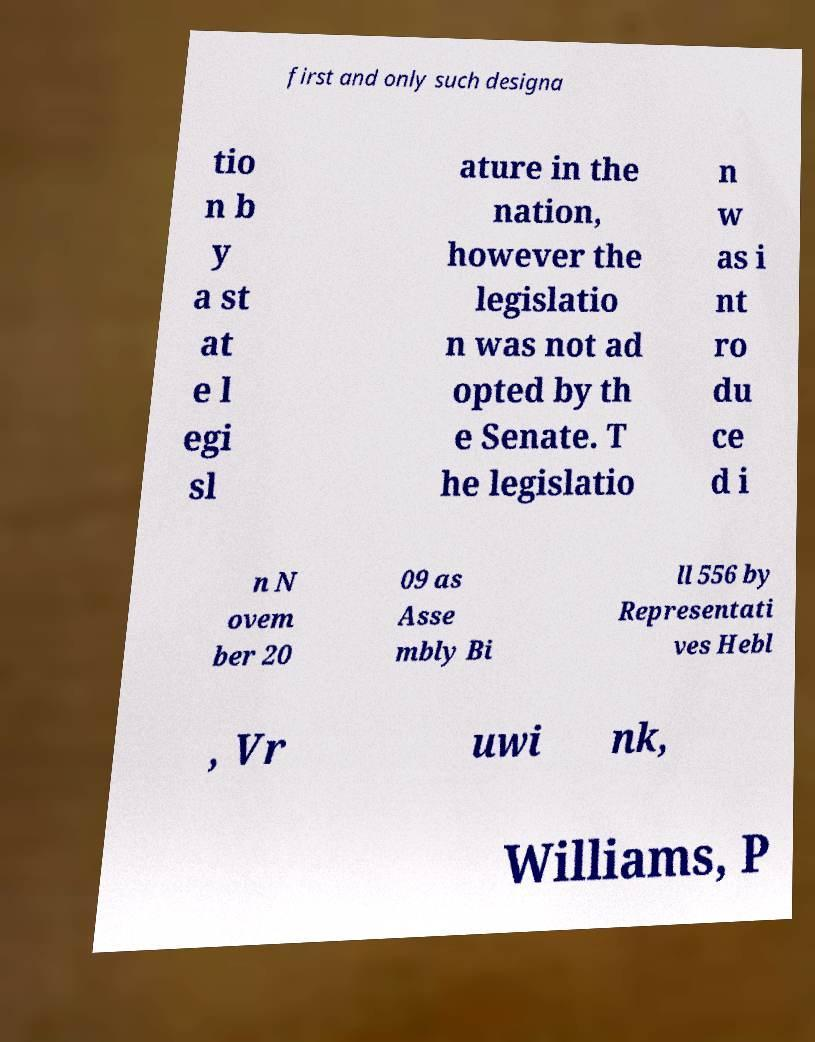For documentation purposes, I need the text within this image transcribed. Could you provide that? first and only such designa tio n b y a st at e l egi sl ature in the nation, however the legislatio n was not ad opted by th e Senate. T he legislatio n w as i nt ro du ce d i n N ovem ber 20 09 as Asse mbly Bi ll 556 by Representati ves Hebl , Vr uwi nk, Williams, P 